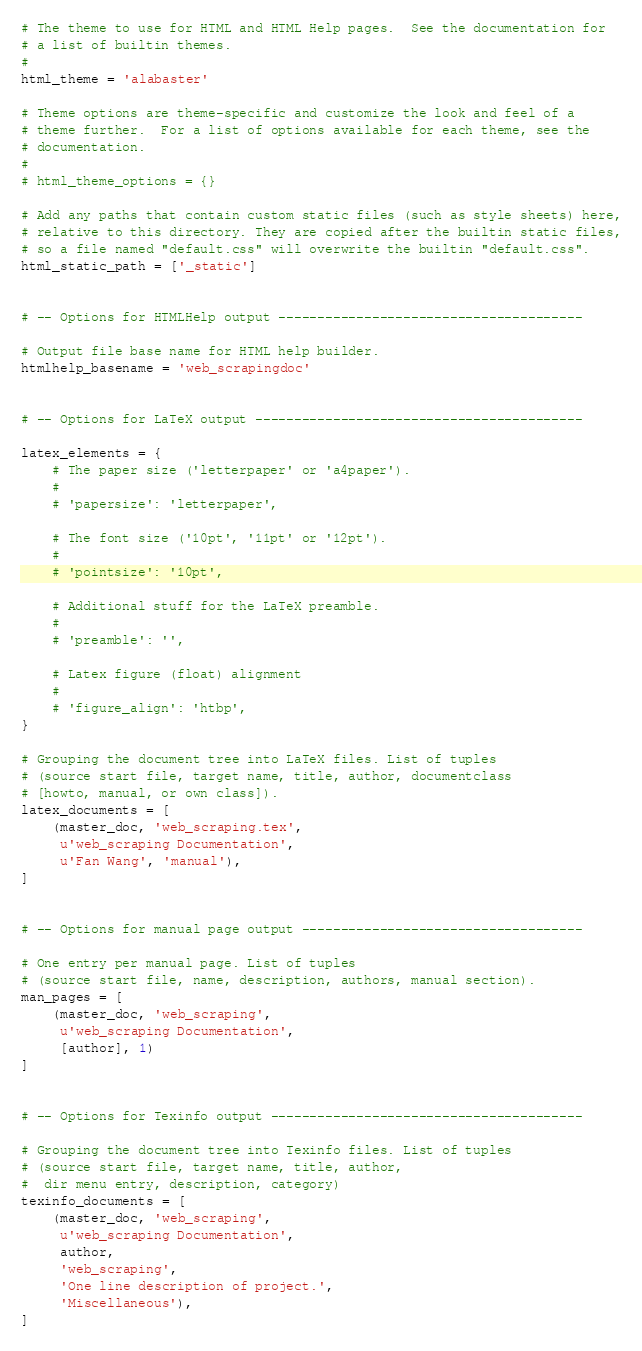<code> <loc_0><loc_0><loc_500><loc_500><_Python_>
# The theme to use for HTML and HTML Help pages.  See the documentation for
# a list of builtin themes.
#
html_theme = 'alabaster'

# Theme options are theme-specific and customize the look and feel of a
# theme further.  For a list of options available for each theme, see the
# documentation.
#
# html_theme_options = {}

# Add any paths that contain custom static files (such as style sheets) here,
# relative to this directory. They are copied after the builtin static files,
# so a file named "default.css" will overwrite the builtin "default.css".
html_static_path = ['_static']


# -- Options for HTMLHelp output ---------------------------------------

# Output file base name for HTML help builder.
htmlhelp_basename = 'web_scrapingdoc'


# -- Options for LaTeX output ------------------------------------------

latex_elements = {
    # The paper size ('letterpaper' or 'a4paper').
    #
    # 'papersize': 'letterpaper',

    # The font size ('10pt', '11pt' or '12pt').
    #
    # 'pointsize': '10pt',

    # Additional stuff for the LaTeX preamble.
    #
    # 'preamble': '',

    # Latex figure (float) alignment
    #
    # 'figure_align': 'htbp',
}

# Grouping the document tree into LaTeX files. List of tuples
# (source start file, target name, title, author, documentclass
# [howto, manual, or own class]).
latex_documents = [
    (master_doc, 'web_scraping.tex',
     u'web_scraping Documentation',
     u'Fan Wang', 'manual'),
]


# -- Options for manual page output ------------------------------------

# One entry per manual page. List of tuples
# (source start file, name, description, authors, manual section).
man_pages = [
    (master_doc, 'web_scraping',
     u'web_scraping Documentation',
     [author], 1)
]


# -- Options for Texinfo output ----------------------------------------

# Grouping the document tree into Texinfo files. List of tuples
# (source start file, target name, title, author,
#  dir menu entry, description, category)
texinfo_documents = [
    (master_doc, 'web_scraping',
     u'web_scraping Documentation',
     author,
     'web_scraping',
     'One line description of project.',
     'Miscellaneous'),
]



</code> 